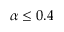<formula> <loc_0><loc_0><loc_500><loc_500>\alpha \leq 0 . 4</formula> 